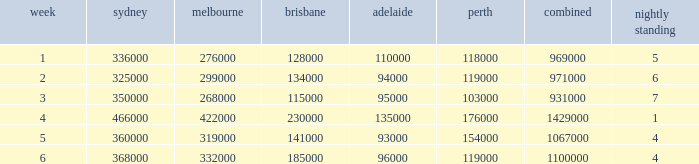What was the rating for Brisbane the week that Adelaide had 94000? 134000.0. 